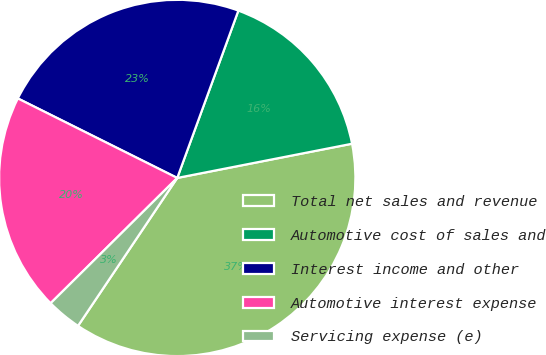<chart> <loc_0><loc_0><loc_500><loc_500><pie_chart><fcel>Total net sales and revenue<fcel>Automotive cost of sales and<fcel>Interest income and other<fcel>Automotive interest expense<fcel>Servicing expense (e)<nl><fcel>37.48%<fcel>16.35%<fcel>23.21%<fcel>19.78%<fcel>3.18%<nl></chart> 